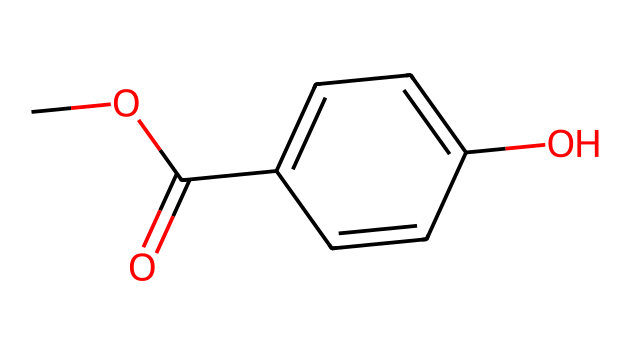What is the functional group present in this chemical structure? The chemical structure contains an ester functional group, seen in the -COO- segment. A carbonyl (C=O) adjacent to an oxygen atom indicates this is an ester.
Answer: ester How many aromatic rings are in the structure? The structure includes one aromatic ring, evident from the alternating double bonds indicated in the cyclic portion of the molecule.
Answer: one What is the total number of carbon atoms in the chemical structure? By analyzing the SMILES representation, we can count that there are seven carbon atoms in total: five in the aromatic ring and two in the side chain (one from the carbonyl and one from the methoxy group).
Answer: seven What is the name of this chemical? The chemical structure corresponds to methylparaben, which is identified as a commonly used paraben in cosmetics. The presence of a methoxy group (-OCH3) and a para-hydroxy group indicates it is methylparaben.
Answer: methylparaben What type of chemical is methylparaben considered? Methylparaben is classified as a preservative due to its function in preventing microbial growth in cosmetic products. It is specifically a paraben, known for its effectiveness as a preservative.
Answer: preservative Which part of this chemical makes it soluble in alcohol? The presence of the methoxy group (-OCH3) increases the solubility of methylparaben in alcohol. The oxygen atom promotes hydrogen bonding with polar solvents like alcohol.
Answer: methoxy group 